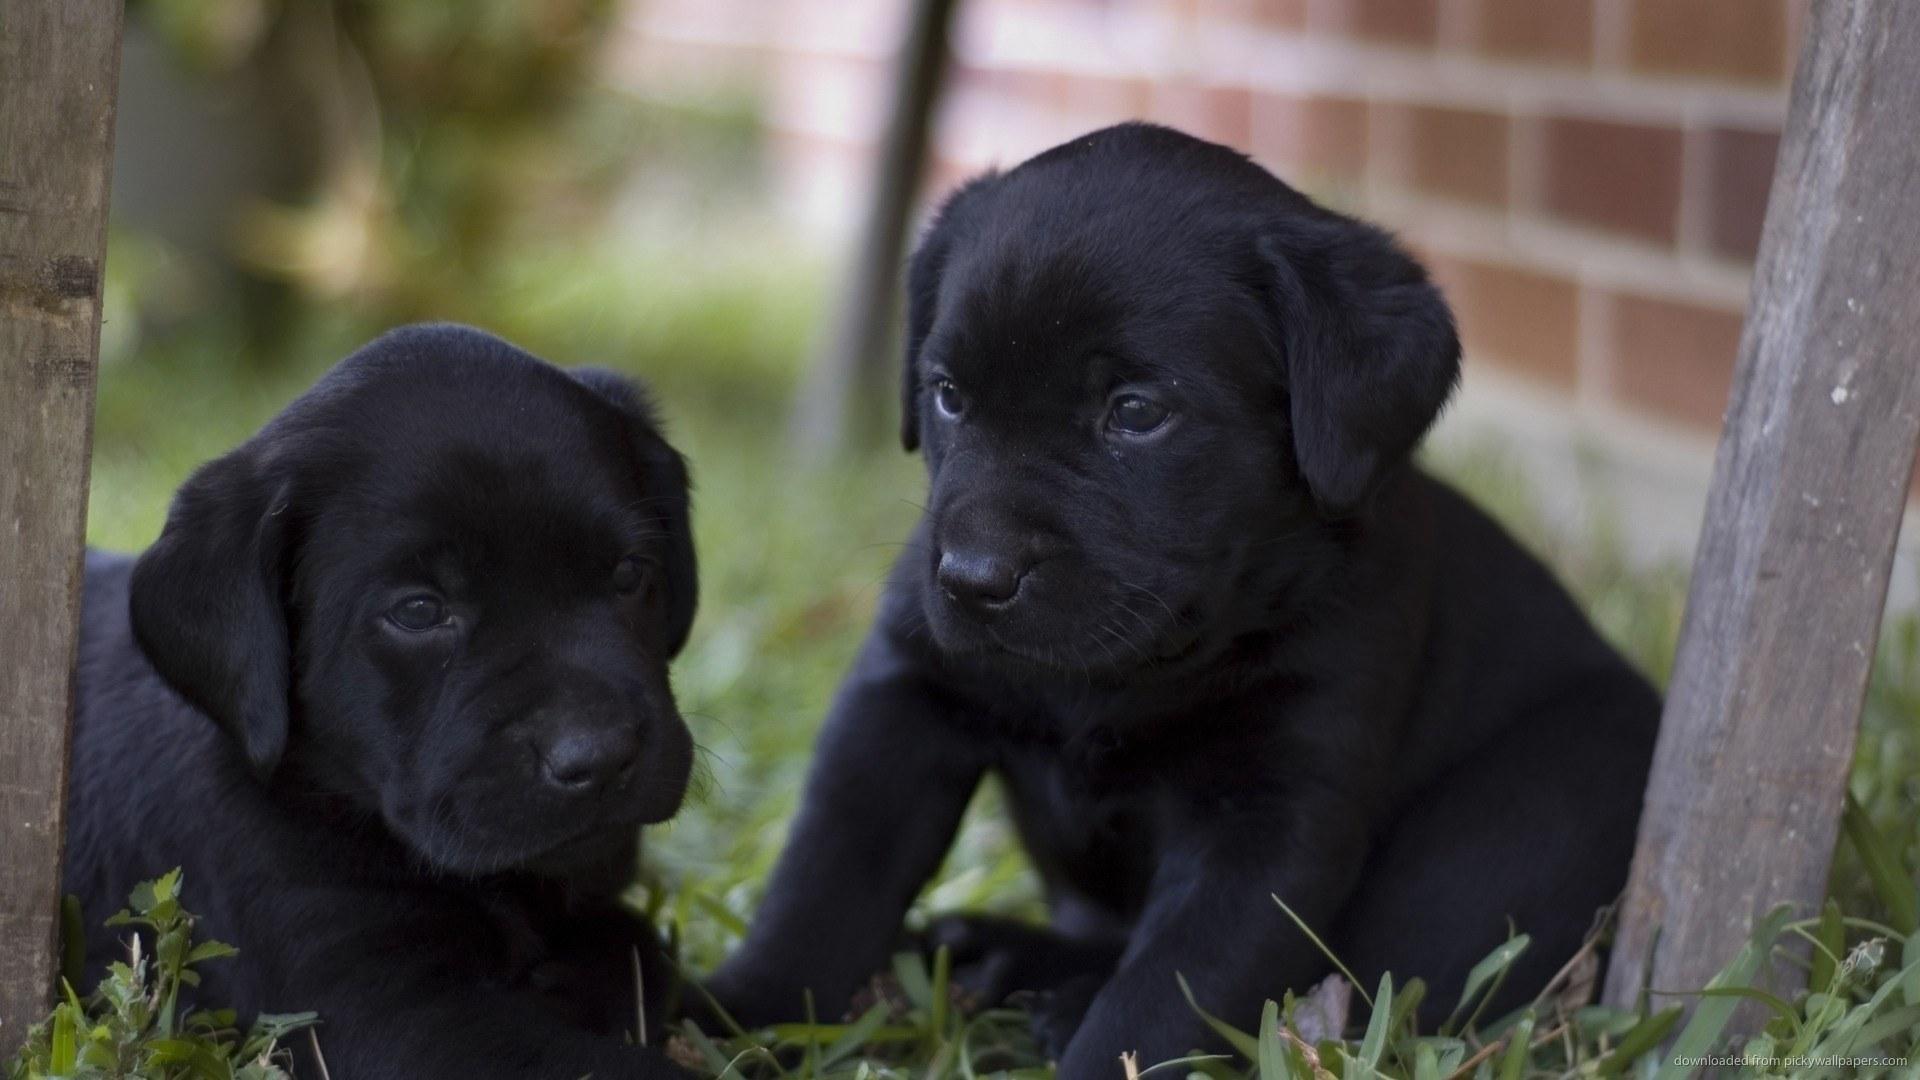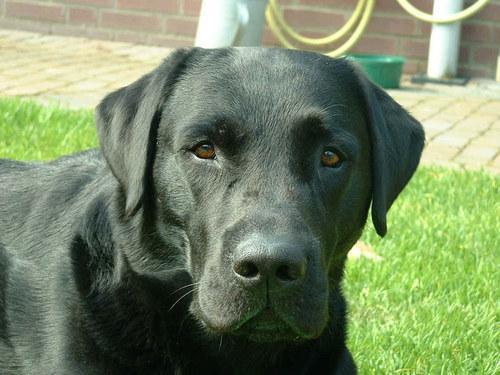The first image is the image on the left, the second image is the image on the right. Examine the images to the left and right. Is the description "One image contains at least two all-black lab puppies posed side-by-side outdoors." accurate? Answer yes or no. Yes. The first image is the image on the left, the second image is the image on the right. Assess this claim about the two images: "The left image contains at least two black dogs.". Correct or not? Answer yes or no. Yes. 